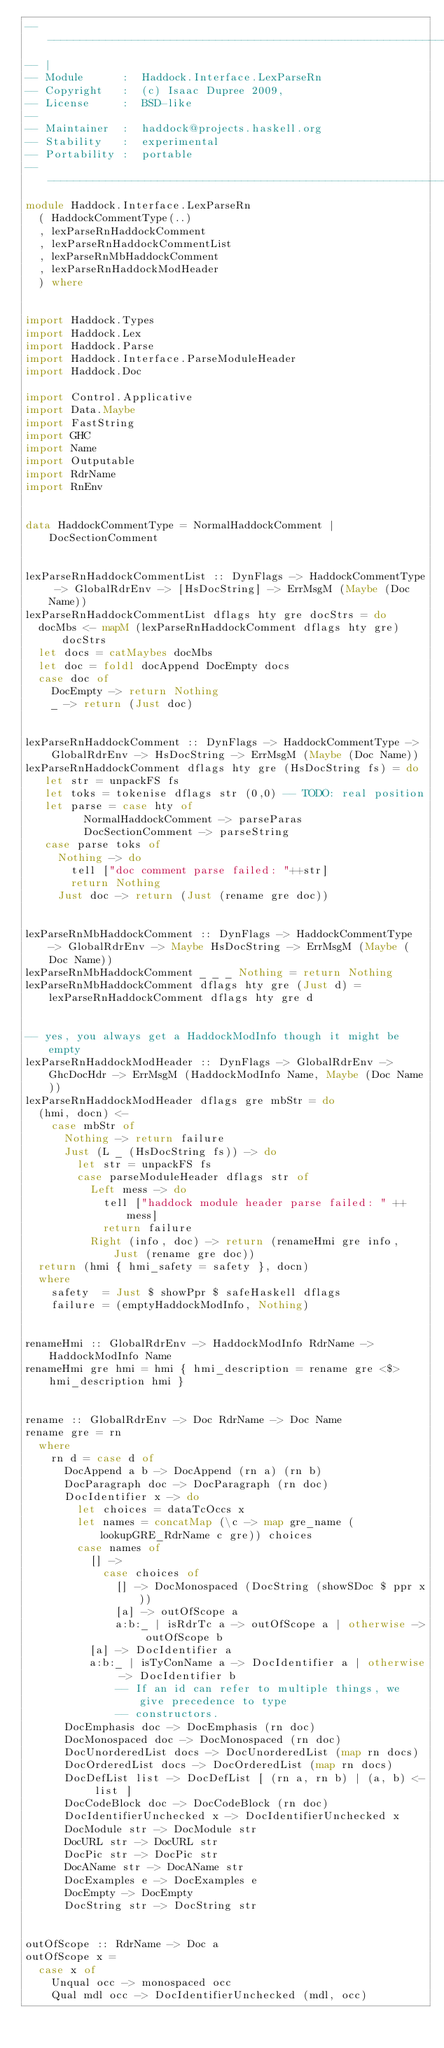<code> <loc_0><loc_0><loc_500><loc_500><_Haskell_>-----------------------------------------------------------------------------
-- |
-- Module      :  Haddock.Interface.LexParseRn
-- Copyright   :  (c) Isaac Dupree 2009,
-- License     :  BSD-like
--
-- Maintainer  :  haddock@projects.haskell.org
-- Stability   :  experimental
-- Portability :  portable
-----------------------------------------------------------------------------
module Haddock.Interface.LexParseRn
  ( HaddockCommentType(..)
  , lexParseRnHaddockComment
  , lexParseRnHaddockCommentList
  , lexParseRnMbHaddockComment
  , lexParseRnHaddockModHeader
  ) where


import Haddock.Types
import Haddock.Lex
import Haddock.Parse
import Haddock.Interface.ParseModuleHeader
import Haddock.Doc

import Control.Applicative
import Data.Maybe
import FastString
import GHC
import Name
import Outputable
import RdrName
import RnEnv


data HaddockCommentType = NormalHaddockComment | DocSectionComment


lexParseRnHaddockCommentList :: DynFlags -> HaddockCommentType -> GlobalRdrEnv -> [HsDocString] -> ErrMsgM (Maybe (Doc Name))
lexParseRnHaddockCommentList dflags hty gre docStrs = do
  docMbs <- mapM (lexParseRnHaddockComment dflags hty gre) docStrs
  let docs = catMaybes docMbs
  let doc = foldl docAppend DocEmpty docs
  case doc of
    DocEmpty -> return Nothing
    _ -> return (Just doc)


lexParseRnHaddockComment :: DynFlags -> HaddockCommentType ->
    GlobalRdrEnv -> HsDocString -> ErrMsgM (Maybe (Doc Name))
lexParseRnHaddockComment dflags hty gre (HsDocString fs) = do
   let str = unpackFS fs
   let toks = tokenise dflags str (0,0) -- TODO: real position
   let parse = case hty of
         NormalHaddockComment -> parseParas
         DocSectionComment -> parseString
   case parse toks of
     Nothing -> do
       tell ["doc comment parse failed: "++str]
       return Nothing
     Just doc -> return (Just (rename gre doc))


lexParseRnMbHaddockComment :: DynFlags -> HaddockCommentType -> GlobalRdrEnv -> Maybe HsDocString -> ErrMsgM (Maybe (Doc Name))
lexParseRnMbHaddockComment _ _ _ Nothing = return Nothing
lexParseRnMbHaddockComment dflags hty gre (Just d) = lexParseRnHaddockComment dflags hty gre d


-- yes, you always get a HaddockModInfo though it might be empty
lexParseRnHaddockModHeader :: DynFlags -> GlobalRdrEnv -> GhcDocHdr -> ErrMsgM (HaddockModInfo Name, Maybe (Doc Name))
lexParseRnHaddockModHeader dflags gre mbStr = do
  (hmi, docn) <-
    case mbStr of
      Nothing -> return failure
      Just (L _ (HsDocString fs)) -> do
        let str = unpackFS fs
        case parseModuleHeader dflags str of
          Left mess -> do
            tell ["haddock module header parse failed: " ++ mess]
            return failure
          Right (info, doc) -> return (renameHmi gre info, Just (rename gre doc))
  return (hmi { hmi_safety = safety }, docn)
  where
    safety  = Just $ showPpr $ safeHaskell dflags
    failure = (emptyHaddockModInfo, Nothing)


renameHmi :: GlobalRdrEnv -> HaddockModInfo RdrName -> HaddockModInfo Name
renameHmi gre hmi = hmi { hmi_description = rename gre <$> hmi_description hmi }


rename :: GlobalRdrEnv -> Doc RdrName -> Doc Name
rename gre = rn
  where
    rn d = case d of
      DocAppend a b -> DocAppend (rn a) (rn b)
      DocParagraph doc -> DocParagraph (rn doc)
      DocIdentifier x -> do
        let choices = dataTcOccs x
        let names = concatMap (\c -> map gre_name (lookupGRE_RdrName c gre)) choices
        case names of
          [] ->
            case choices of
              [] -> DocMonospaced (DocString (showSDoc $ ppr x))
              [a] -> outOfScope a
              a:b:_ | isRdrTc a -> outOfScope a | otherwise -> outOfScope b
          [a] -> DocIdentifier a
          a:b:_ | isTyConName a -> DocIdentifier a | otherwise -> DocIdentifier b
              -- If an id can refer to multiple things, we give precedence to type
              -- constructors.
      DocEmphasis doc -> DocEmphasis (rn doc)
      DocMonospaced doc -> DocMonospaced (rn doc)
      DocUnorderedList docs -> DocUnorderedList (map rn docs)
      DocOrderedList docs -> DocOrderedList (map rn docs)
      DocDefList list -> DocDefList [ (rn a, rn b) | (a, b) <- list ]
      DocCodeBlock doc -> DocCodeBlock (rn doc)
      DocIdentifierUnchecked x -> DocIdentifierUnchecked x
      DocModule str -> DocModule str
      DocURL str -> DocURL str
      DocPic str -> DocPic str
      DocAName str -> DocAName str
      DocExamples e -> DocExamples e
      DocEmpty -> DocEmpty
      DocString str -> DocString str


outOfScope :: RdrName -> Doc a
outOfScope x =
  case x of
    Unqual occ -> monospaced occ
    Qual mdl occ -> DocIdentifierUnchecked (mdl, occ)</code> 